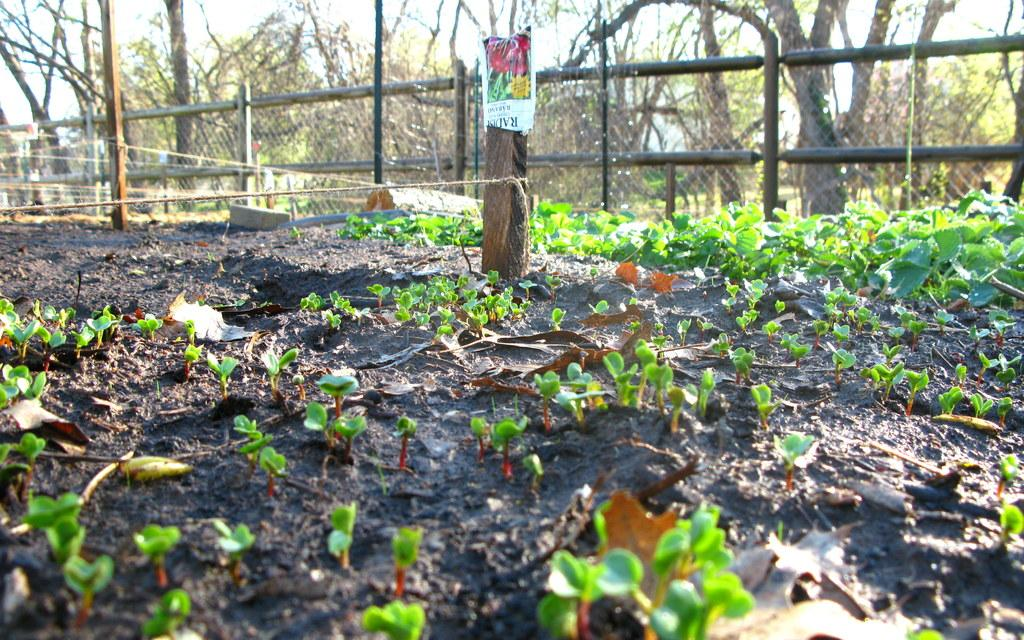What is located in the foreground of the picture? In the foreground of the picture, there are plants, mud, a rope, and wooden poles. What can be seen in the background of the picture? In the background of the picture, there are trees, fencing, and the sky. What type of vegetation is present in the foreground of the picture? The vegetation in the foreground of the picture consists of plants. What is the purpose of the wooden poles in the foreground of the picture? The wooden poles in the foreground of the picture may be used for support or as part of a structure. What historical attraction can be seen in the background of the picture? There is no historical attraction visible in the background of the picture. How does the rope control the movement of the plants in the foreground of the picture? The rope does not control the movement of the plants in the foreground of the picture; it is simply present in the image. 